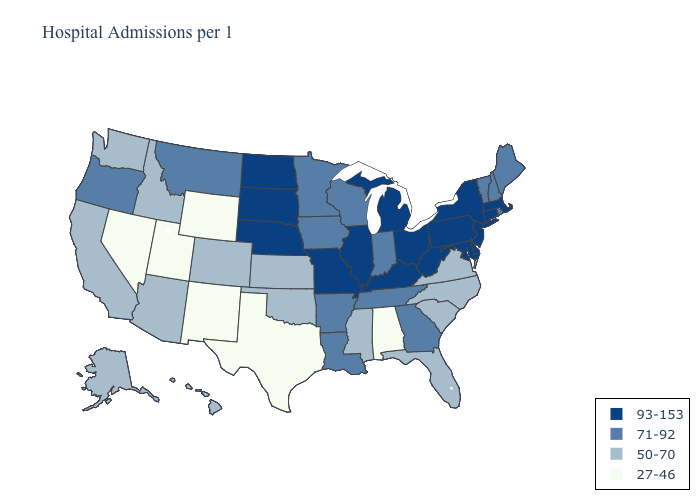What is the lowest value in states that border Tennessee?
Short answer required. 27-46. Name the states that have a value in the range 27-46?
Concise answer only. Alabama, Nevada, New Mexico, Texas, Utah, Wyoming. Does Nevada have the highest value in the USA?
Answer briefly. No. Does Utah have the lowest value in the USA?
Give a very brief answer. Yes. What is the value of Connecticut?
Concise answer only. 93-153. What is the value of Colorado?
Keep it brief. 50-70. What is the lowest value in states that border Minnesota?
Write a very short answer. 71-92. What is the value of Oregon?
Quick response, please. 71-92. Which states hav the highest value in the West?
Short answer required. Montana, Oregon. Does Texas have the lowest value in the USA?
Give a very brief answer. Yes. Does Vermont have the same value as Connecticut?
Be succinct. No. What is the value of Utah?
Answer briefly. 27-46. Name the states that have a value in the range 50-70?
Be succinct. Alaska, Arizona, California, Colorado, Florida, Hawaii, Idaho, Kansas, Mississippi, North Carolina, Oklahoma, South Carolina, Virginia, Washington. Does Alaska have the highest value in the USA?
Concise answer only. No. Among the states that border Wyoming , which have the highest value?
Be succinct. Nebraska, South Dakota. 